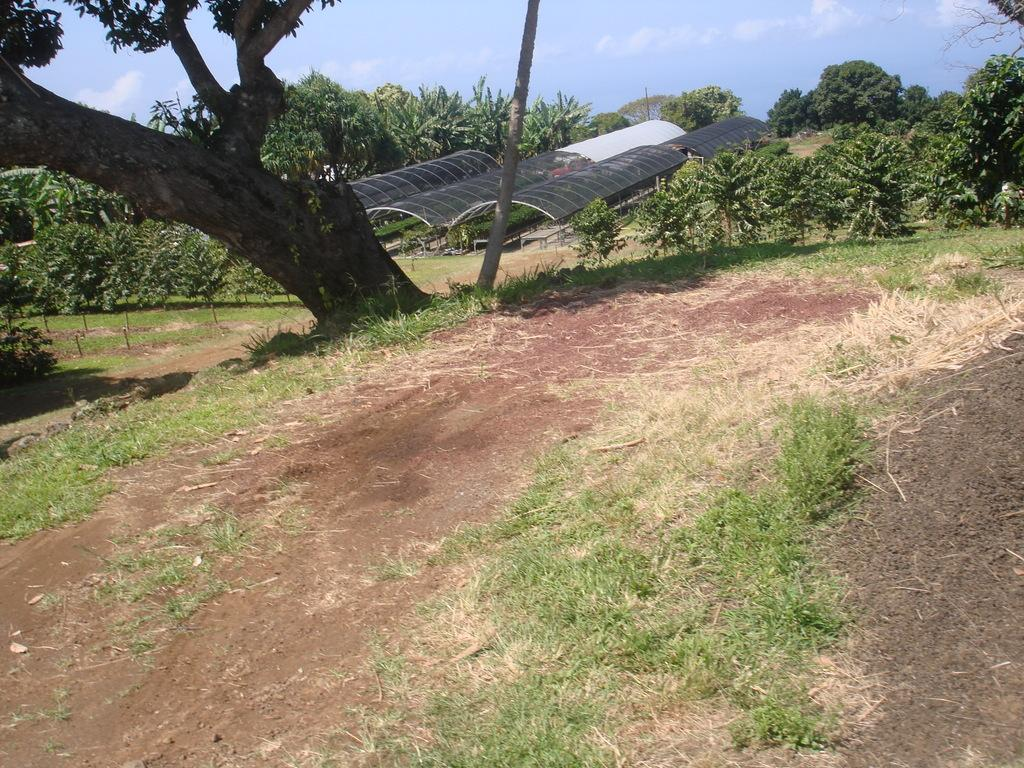What type of vegetation can be seen in the image? There is a tree and grass in the image. What structure is present in the image? There is a pole in the image. What type of path is visible in the image? There is a walkway in the image. What can be seen in the background of the image? In the background, there are trees, plants, grass, poles, and shelters. What is visible at the top of the image? The sky is visible at the top of the image. What type of plant is being played on in the image? There is no plant being played on in the image. What is the base of the tree made of in the image? The facts provided do not mention the base of the tree or its material. 